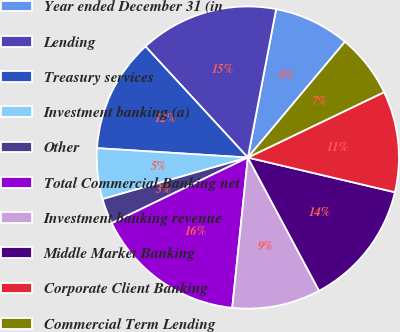Convert chart. <chart><loc_0><loc_0><loc_500><loc_500><pie_chart><fcel>Year ended December 31 (in<fcel>Lending<fcel>Treasury services<fcel>Investment banking (a)<fcel>Other<fcel>Total Commercial Banking net<fcel>Investment banking revenue<fcel>Middle Market Banking<fcel>Corporate Client Banking<fcel>Commercial Term Lending<nl><fcel>8.11%<fcel>14.85%<fcel>12.16%<fcel>5.42%<fcel>2.72%<fcel>16.2%<fcel>9.46%<fcel>13.5%<fcel>10.81%<fcel>6.77%<nl></chart> 